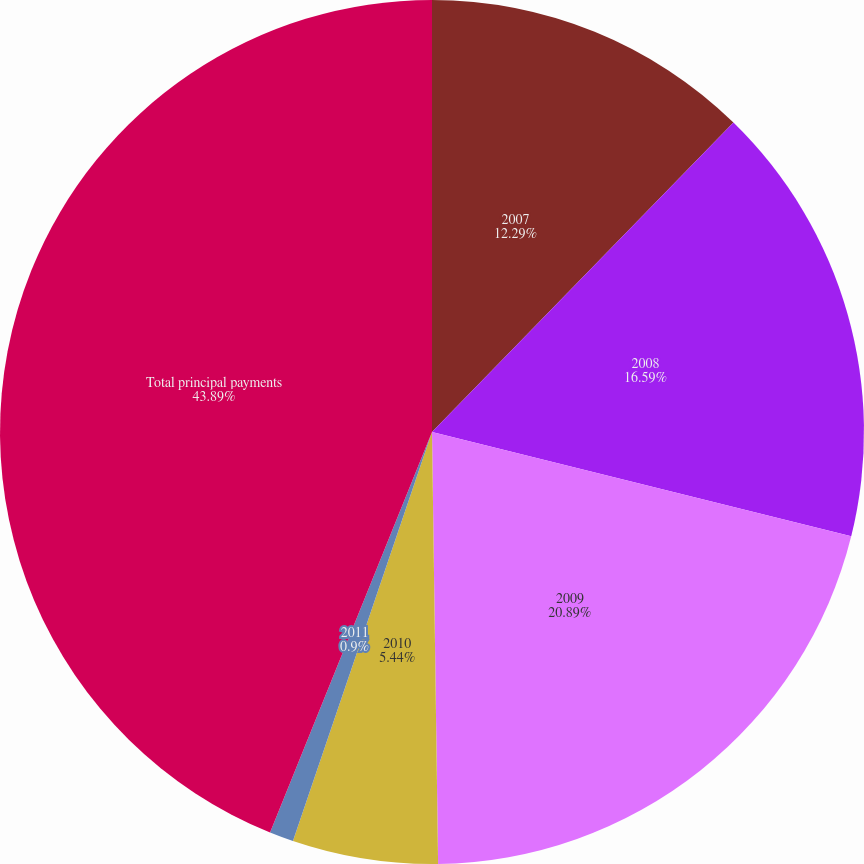<chart> <loc_0><loc_0><loc_500><loc_500><pie_chart><fcel>2007<fcel>2008<fcel>2009<fcel>2010<fcel>2011<fcel>Total principal payments<nl><fcel>12.29%<fcel>16.59%<fcel>20.89%<fcel>5.44%<fcel>0.9%<fcel>43.88%<nl></chart> 